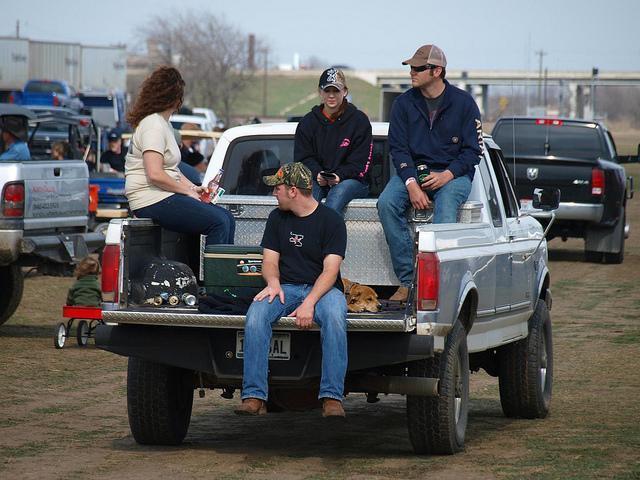How many dogs are in the picture?
Give a very brief answer. 1. How many men in the truck in the back?
Give a very brief answer. 3. How many people are there?
Give a very brief answer. 4. How many trucks are in the photo?
Give a very brief answer. 4. 